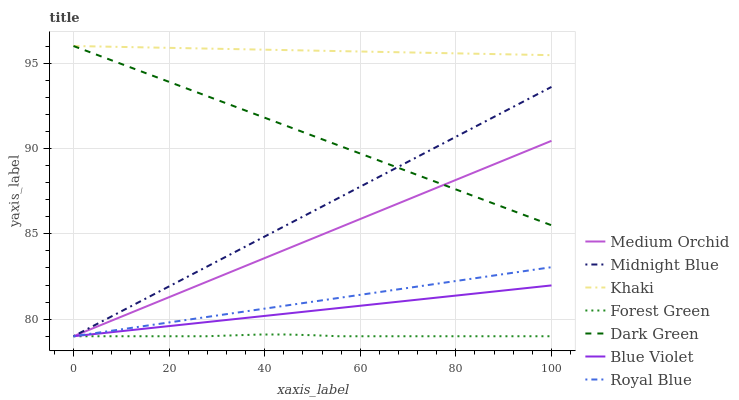Does Forest Green have the minimum area under the curve?
Answer yes or no. Yes. Does Khaki have the maximum area under the curve?
Answer yes or no. Yes. Does Midnight Blue have the minimum area under the curve?
Answer yes or no. No. Does Midnight Blue have the maximum area under the curve?
Answer yes or no. No. Is Blue Violet the smoothest?
Answer yes or no. Yes. Is Forest Green the roughest?
Answer yes or no. Yes. Is Midnight Blue the smoothest?
Answer yes or no. No. Is Midnight Blue the roughest?
Answer yes or no. No. Does Midnight Blue have the lowest value?
Answer yes or no. Yes. Does Dark Green have the lowest value?
Answer yes or no. No. Does Dark Green have the highest value?
Answer yes or no. Yes. Does Midnight Blue have the highest value?
Answer yes or no. No. Is Royal Blue less than Khaki?
Answer yes or no. Yes. Is Khaki greater than Blue Violet?
Answer yes or no. Yes. Does Blue Violet intersect Royal Blue?
Answer yes or no. Yes. Is Blue Violet less than Royal Blue?
Answer yes or no. No. Is Blue Violet greater than Royal Blue?
Answer yes or no. No. Does Royal Blue intersect Khaki?
Answer yes or no. No. 